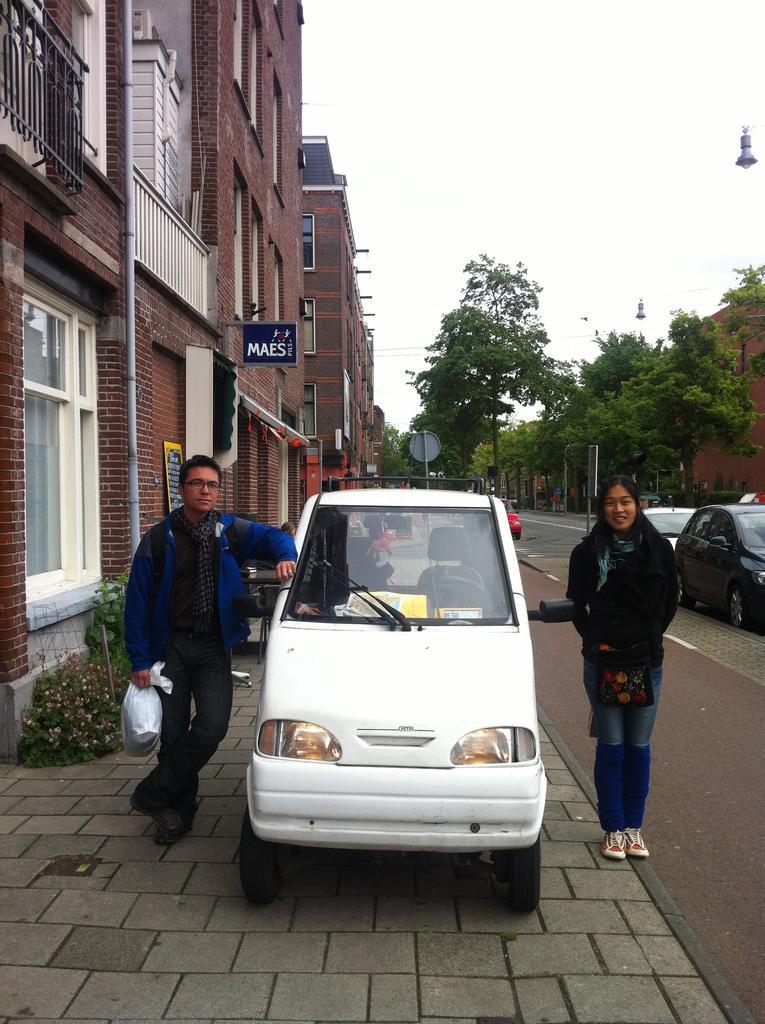Can you describe this image briefly? In this image I can see two people standing to the side of the vehicle. These people are wearing the different color dresses. To the right I can see few more vehicles on the road. To the left I can see the building and boards to it. In the background there are many trees and the sky. 